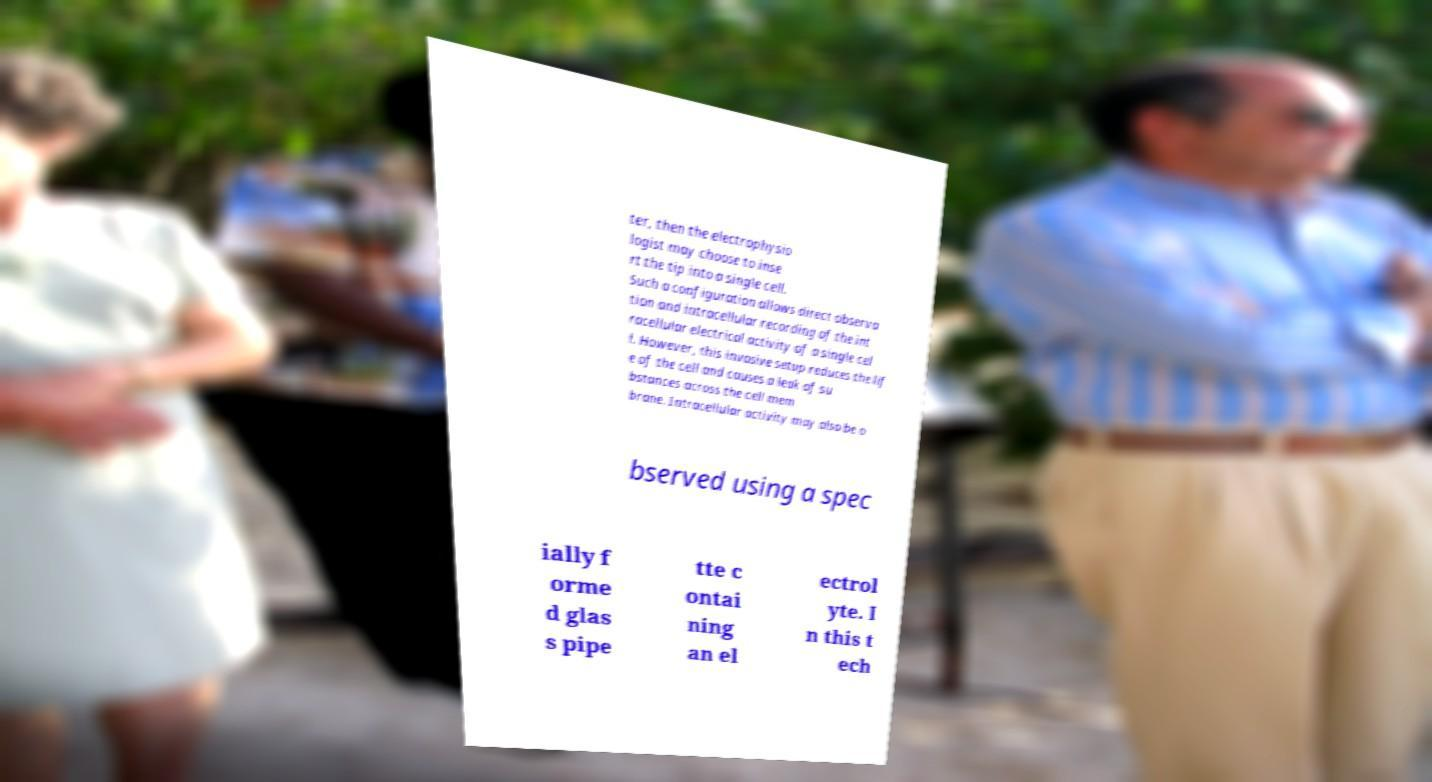For documentation purposes, I need the text within this image transcribed. Could you provide that? ter, then the electrophysio logist may choose to inse rt the tip into a single cell. Such a configuration allows direct observa tion and intracellular recording of the int racellular electrical activity of a single cel l. However, this invasive setup reduces the lif e of the cell and causes a leak of su bstances across the cell mem brane. Intracellular activity may also be o bserved using a spec ially f orme d glas s pipe tte c ontai ning an el ectrol yte. I n this t ech 